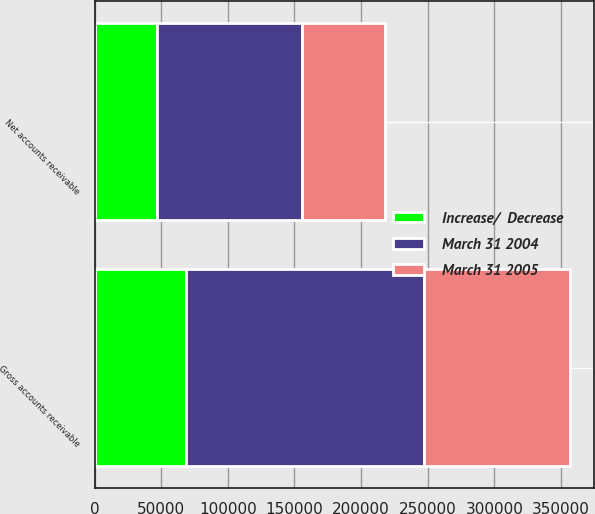Convert chart. <chart><loc_0><loc_0><loc_500><loc_500><stacked_bar_chart><ecel><fcel>Gross accounts receivable<fcel>Net accounts receivable<nl><fcel>March 31 2004<fcel>178335<fcel>109144<nl><fcel>March 31 2005<fcel>109605<fcel>62577<nl><fcel>Increase/  Decrease<fcel>68730<fcel>46567<nl></chart> 